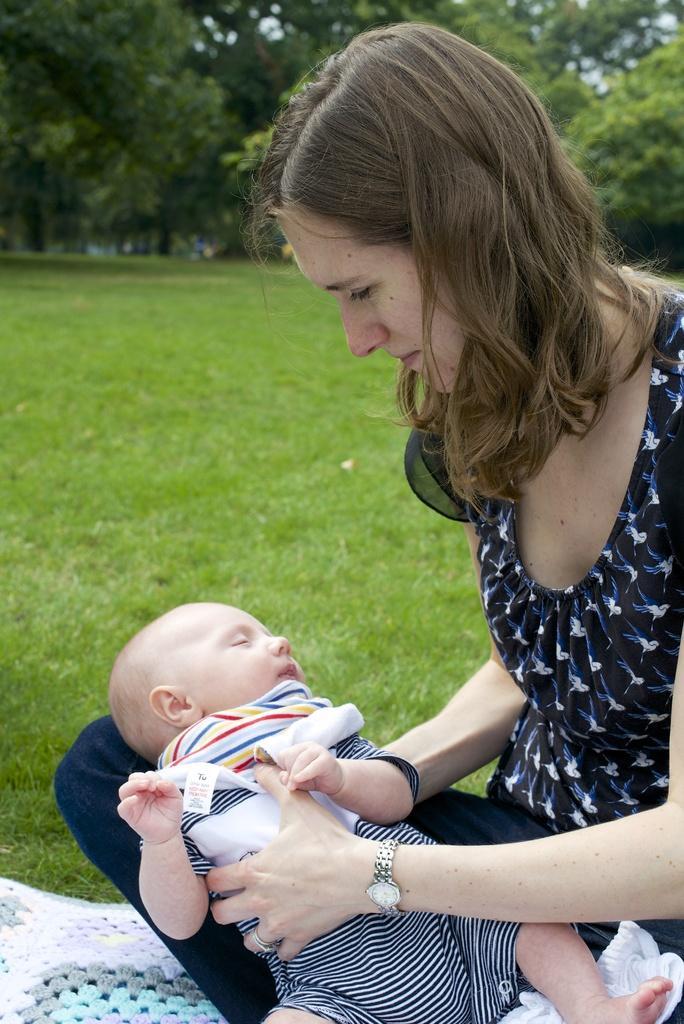Please provide a concise description of this image. In this image we can see a lady and a kid. In the background of the image there are grass, trees, sky and other objects. On the left side bottom of the image there is a cloth. 